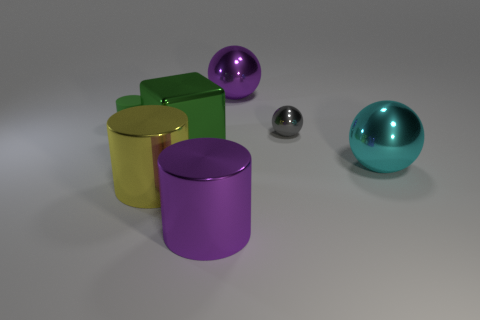Are there any other things that are the same shape as the green shiny thing?
Give a very brief answer. No. Are there fewer cyan balls than tiny brown matte blocks?
Your answer should be very brief. No. What is the shape of the big purple object on the right side of the purple object to the left of the large sphere that is behind the big green block?
Ensure brevity in your answer.  Sphere. Are there any large cyan balls that have the same material as the big green cube?
Provide a short and direct response. Yes. There is a shiny sphere that is behind the tiny green matte object; is it the same color as the big metal cylinder to the right of the big green object?
Offer a very short reply. Yes. Is the number of big metal cylinders that are behind the big green metal block less than the number of large purple metal spheres?
Your answer should be compact. Yes. What number of objects are tiny gray metal things or things in front of the gray metal sphere?
Give a very brief answer. 5. What is the color of the tiny object that is made of the same material as the cyan ball?
Offer a very short reply. Gray. How many things are small gray shiny objects or large yellow things?
Your answer should be compact. 2. What is the color of the other object that is the same size as the matte thing?
Your answer should be very brief. Gray. 